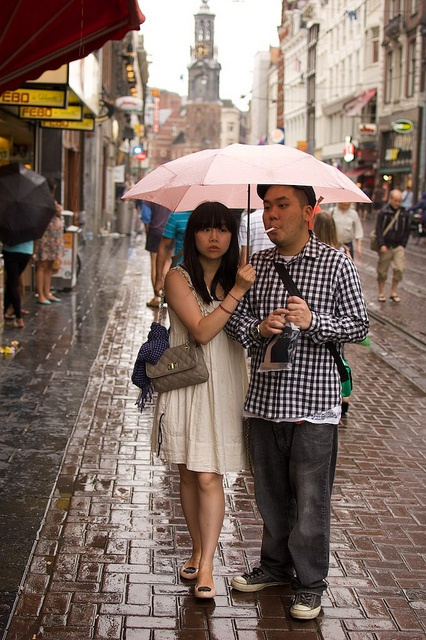Describe the objects in this image and their specific colors. I can see people in maroon, black, gray, and darkgray tones, people in maroon, black, gray, and darkgray tones, umbrella in maroon, lightgray, lightpink, pink, and gray tones, handbag in maroon, black, and gray tones, and umbrella in maroon, black, and gray tones in this image. 